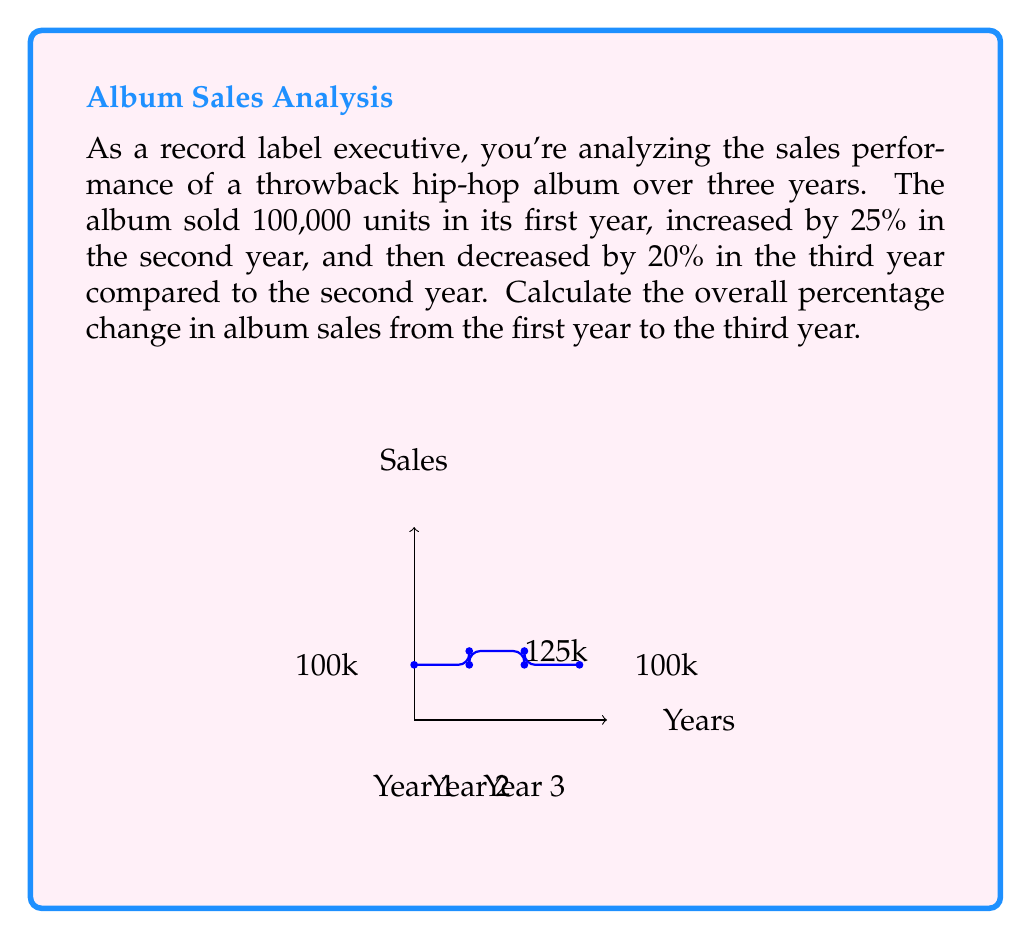Provide a solution to this math problem. Let's approach this step-by-step:

1) First year sales: 100,000 units

2) Second year sales:
   $100,000 \times (1 + 0.25) = 100,000 \times 1.25 = 125,000$ units

3) Third year sales:
   $125,000 \times (1 - 0.20) = 125,000 \times 0.80 = 100,000$ units

4) To calculate the overall percentage change, we use the formula:

   $$\text{Percentage Change} = \frac{\text{Final Value} - \text{Initial Value}}{\text{Initial Value}} \times 100\%$$

5) Plugging in our values:

   $$\text{Percentage Change} = \frac{100,000 - 100,000}{100,000} \times 100\%$$

6) Simplifying:

   $$\text{Percentage Change} = \frac{0}{100,000} \times 100\% = 0\%$$

Therefore, despite the fluctuations in the second and third years, the album sales ended up at the same level as they started, resulting in a 0% overall change.
Answer: 0% 